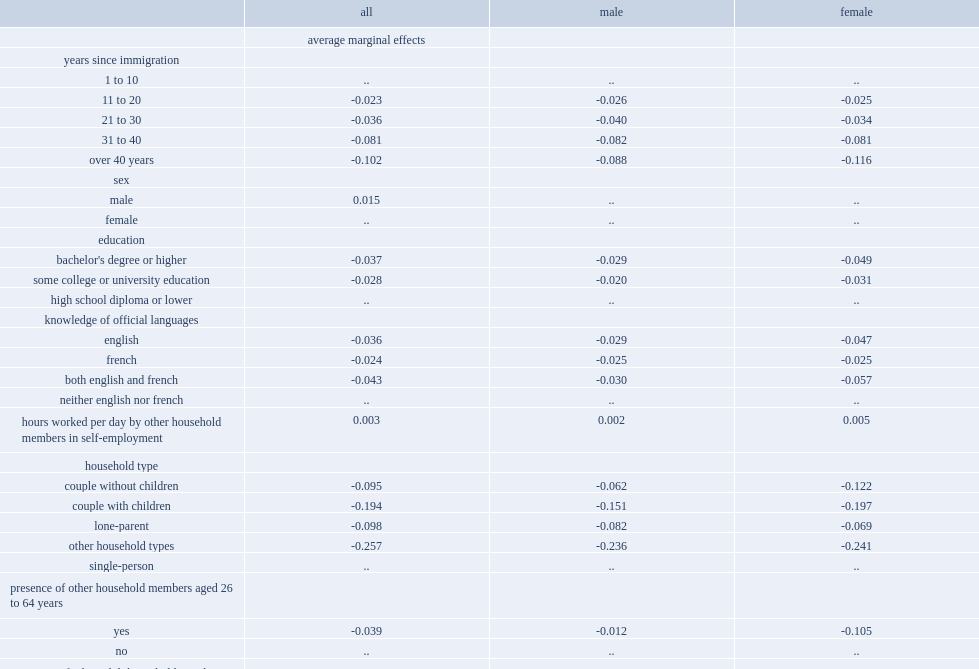What is the proportion of decline in the 11 to 20 years since immigration group is a proxy for senior immigrants who have just met the residency requirement of the oas program in 2016? 0.023. What is the percentage of the probability of being in low income lower among senior immigrants who landed 11 to 20 years ago in 2016? 0.023. What is the percentage of the probability of being in low income lower among senior immigrants who landed 21 to 30 years ago in 2016? 0.036. What is the percentage of the probability of being in low income lower among senior immigrants who landed 31 to 40 years ago in 2016? 0.081. What is the percentage of the probability of being in low income lower among senior immigrants who landed more than 40 years ago in 2016? 0.102. 